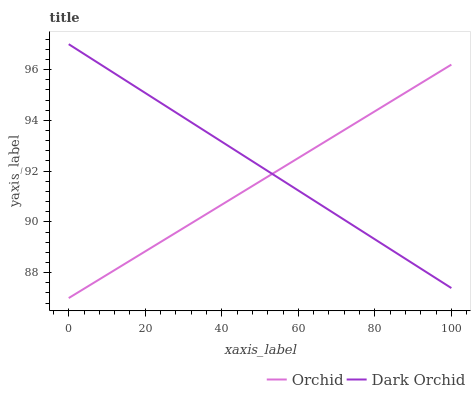Does Orchid have the minimum area under the curve?
Answer yes or no. Yes. Does Dark Orchid have the maximum area under the curve?
Answer yes or no. Yes. Does Orchid have the maximum area under the curve?
Answer yes or no. No. Is Dark Orchid the smoothest?
Answer yes or no. Yes. Is Orchid the roughest?
Answer yes or no. Yes. Is Orchid the smoothest?
Answer yes or no. No. Does Orchid have the lowest value?
Answer yes or no. Yes. Does Dark Orchid have the highest value?
Answer yes or no. Yes. Does Orchid have the highest value?
Answer yes or no. No. Does Orchid intersect Dark Orchid?
Answer yes or no. Yes. Is Orchid less than Dark Orchid?
Answer yes or no. No. Is Orchid greater than Dark Orchid?
Answer yes or no. No. 